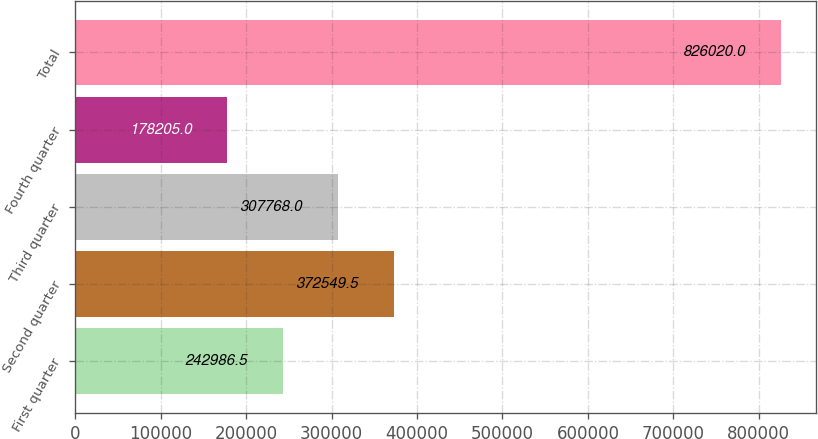Convert chart. <chart><loc_0><loc_0><loc_500><loc_500><bar_chart><fcel>First quarter<fcel>Second quarter<fcel>Third quarter<fcel>Fourth quarter<fcel>Total<nl><fcel>242986<fcel>372550<fcel>307768<fcel>178205<fcel>826020<nl></chart> 